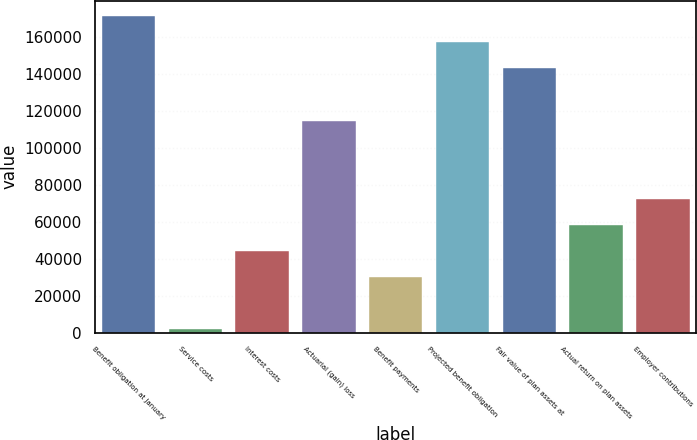<chart> <loc_0><loc_0><loc_500><loc_500><bar_chart><fcel>Benefit obligation at January<fcel>Service costs<fcel>Interest costs<fcel>Actuarial (gain) loss<fcel>Benefit payments<fcel>Projected benefit obligation<fcel>Fair value of plan assets at<fcel>Actual return on plan assets<fcel>Employer contributions<nl><fcel>171394<fcel>1977<fcel>44331.3<fcel>114922<fcel>30213.2<fcel>157276<fcel>143158<fcel>58449.4<fcel>72567.5<nl></chart> 